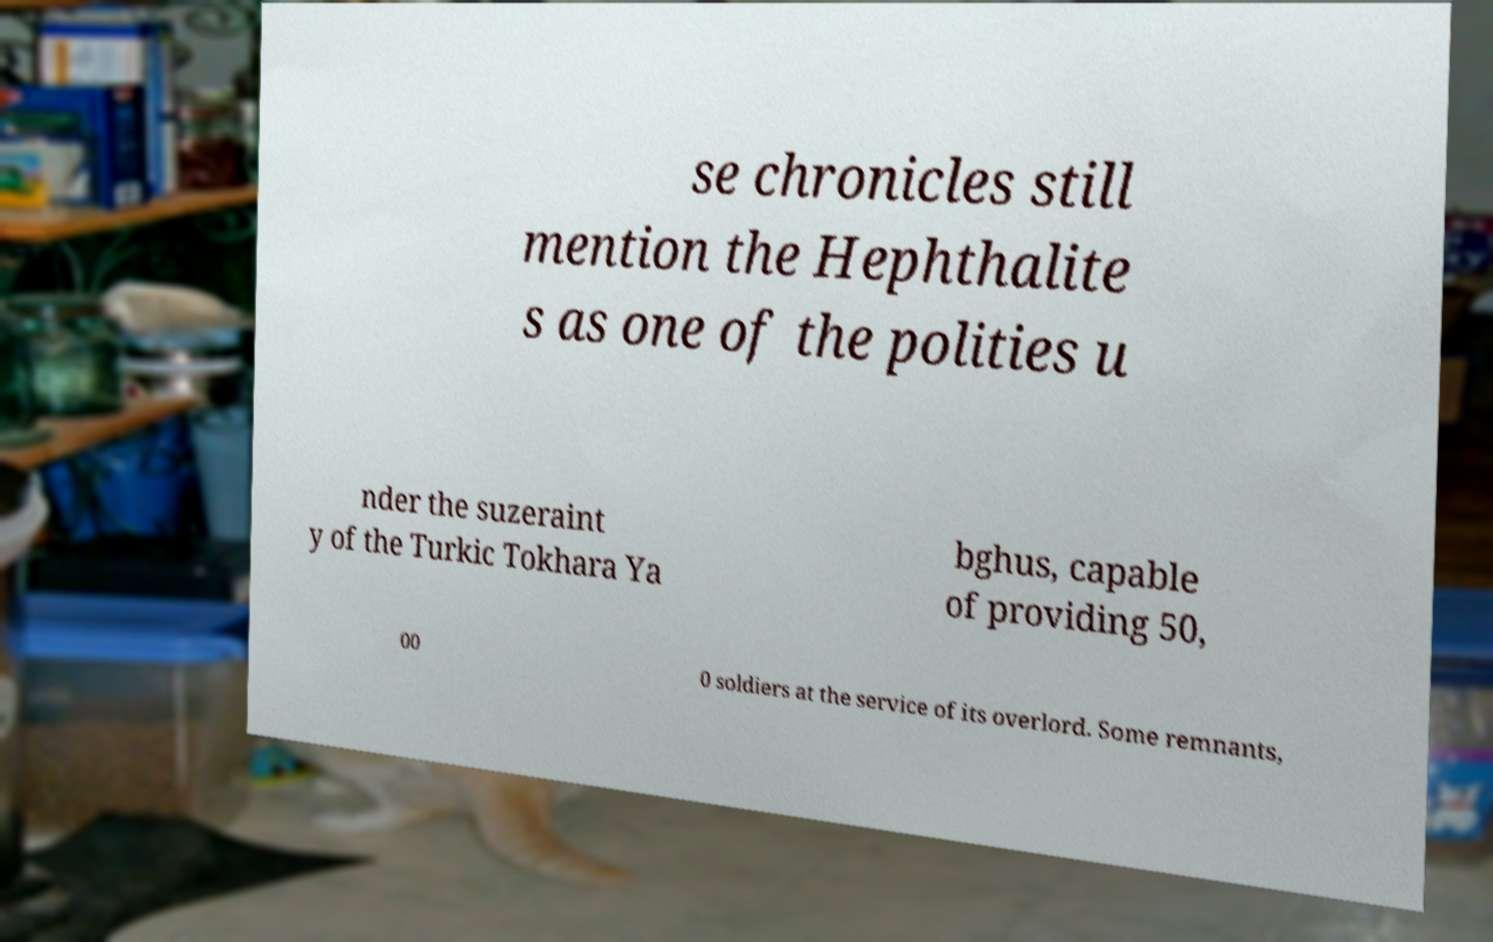Please read and relay the text visible in this image. What does it say? se chronicles still mention the Hephthalite s as one of the polities u nder the suzeraint y of the Turkic Tokhara Ya bghus, capable of providing 50, 00 0 soldiers at the service of its overlord. Some remnants, 